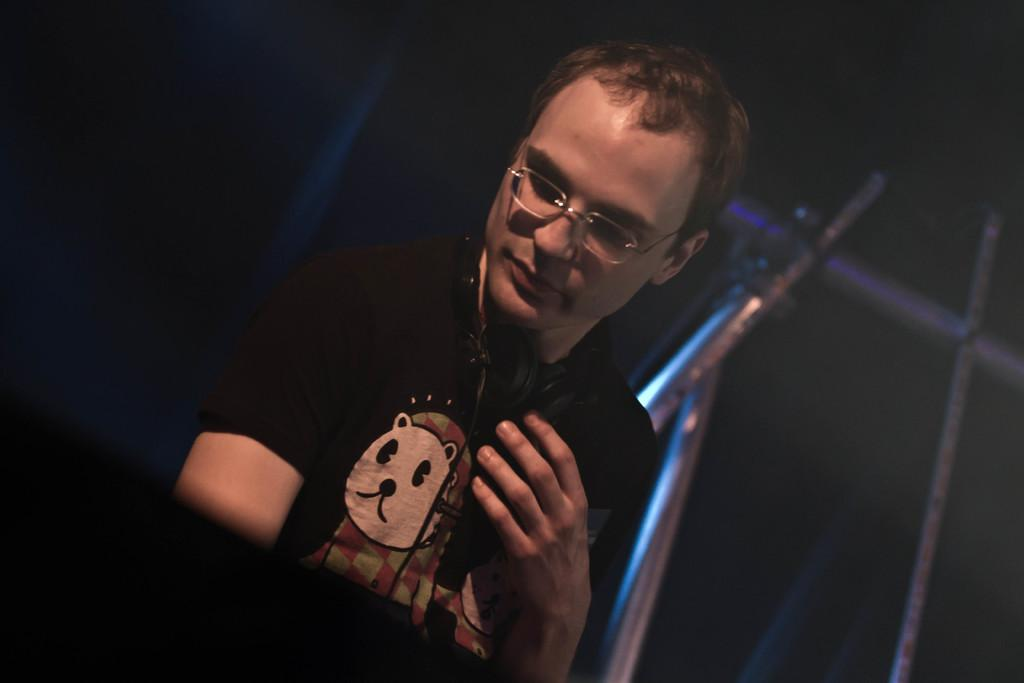Who is present in the image? There is a man in the image. What can be seen on the man's face? The man is wearing spectacles. What is located around the man's neck? There is a headphone around the man's neck. What can be seen in the background of the image? There are objects in the background of the image. What type of winter clothing is the man wearing in the image? The image does not show the man wearing any winter clothing, as it does not depict a winter scene or any specific clothing items associated with winter. 